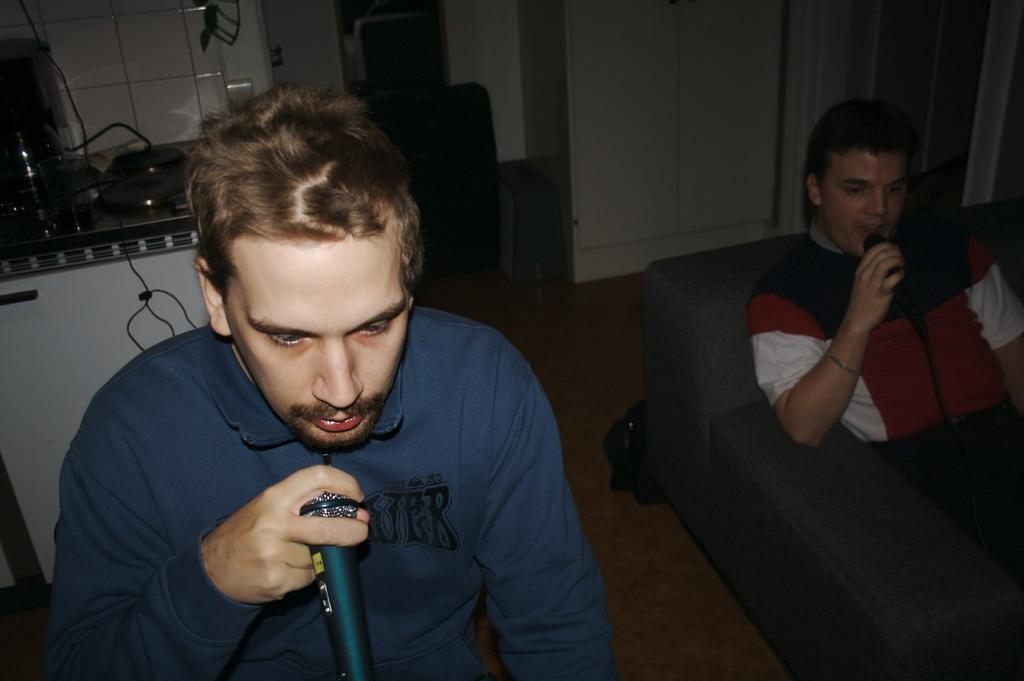How many people are in the room in the image? There are two men in the room. What are the men doing in the image? The men are sitting and holding microphones. What type of furniture is present in the room? There is a wardrobe in the room. What else can be seen on a stand in the room? There is a stand with stuff on it in the room. How many feet can be seen in the image? There are no visible feet in the image. 